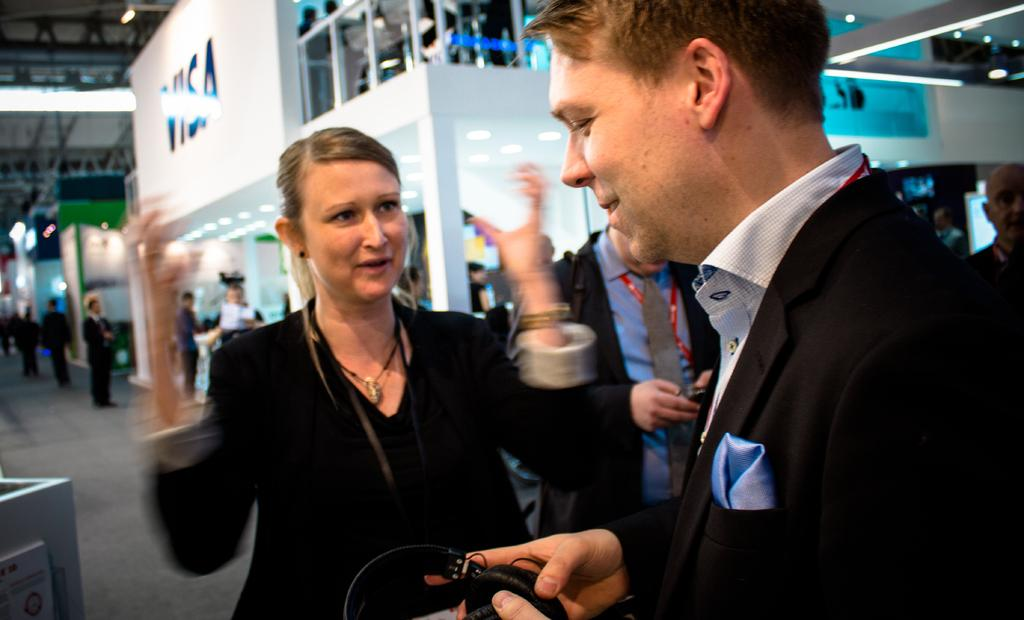What is the main subject of the image? The main subject of the image is a group of persons standing in the center. Where are the persons standing? The group of persons is standing on the floor. What can be seen in the background of the image? There are buildings, persons, lights, iron bars, and the ground visible in the background. What type of drug is being distributed by the frog in the image? There is no frog present in the image, and therefore no such activity can be observed. 